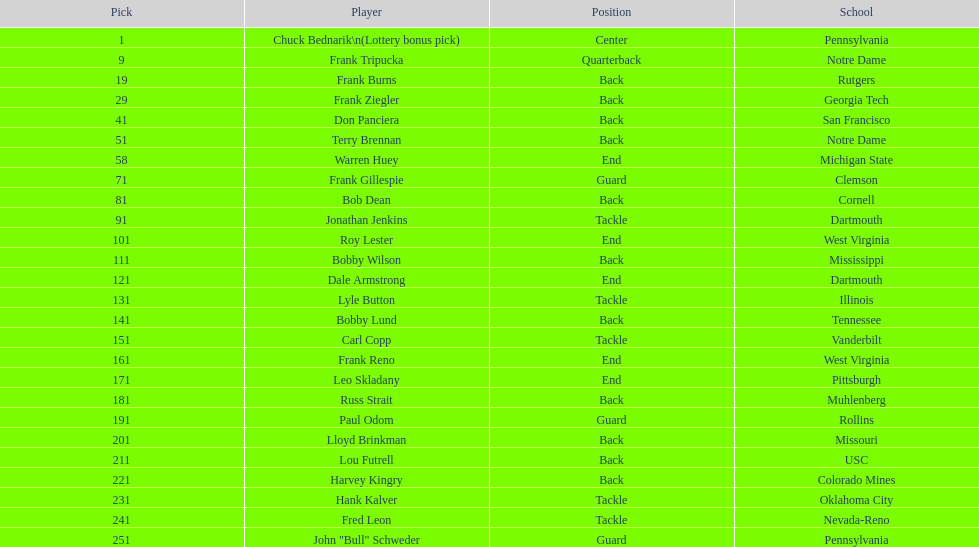Who was picked after frank burns? Frank Ziegler. 